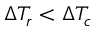Convert formula to latex. <formula><loc_0><loc_0><loc_500><loc_500>\Delta T _ { r } < \Delta T _ { c }</formula> 